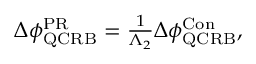Convert formula to latex. <formula><loc_0><loc_0><loc_500><loc_500>\begin{array} { r } { \Delta \phi _ { Q C R B } ^ { P R } = \frac { 1 } { \Lambda _ { 2 } } \Delta \phi _ { Q C R B } ^ { C o n } , } \end{array}</formula> 